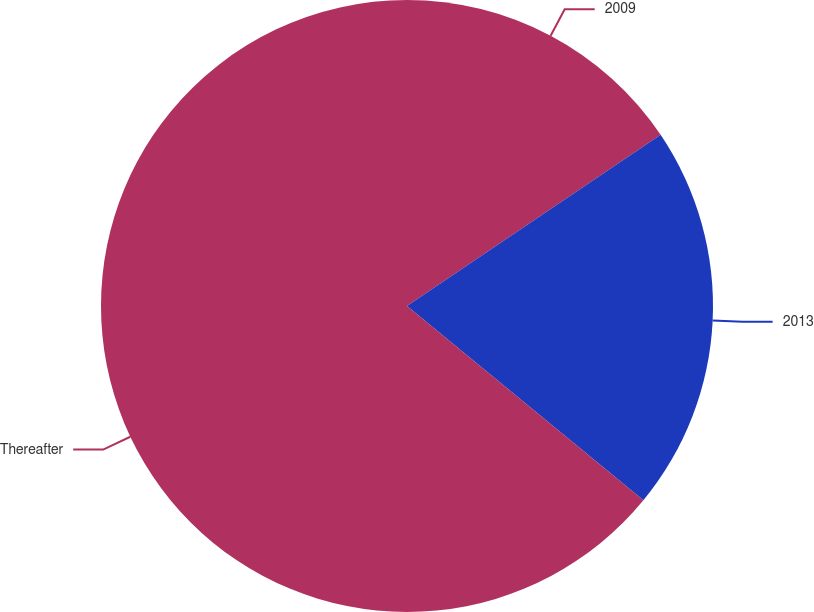<chart> <loc_0><loc_0><loc_500><loc_500><pie_chart><fcel>2009<fcel>2013<fcel>Thereafter<nl><fcel>15.55%<fcel>20.4%<fcel>64.05%<nl></chart> 